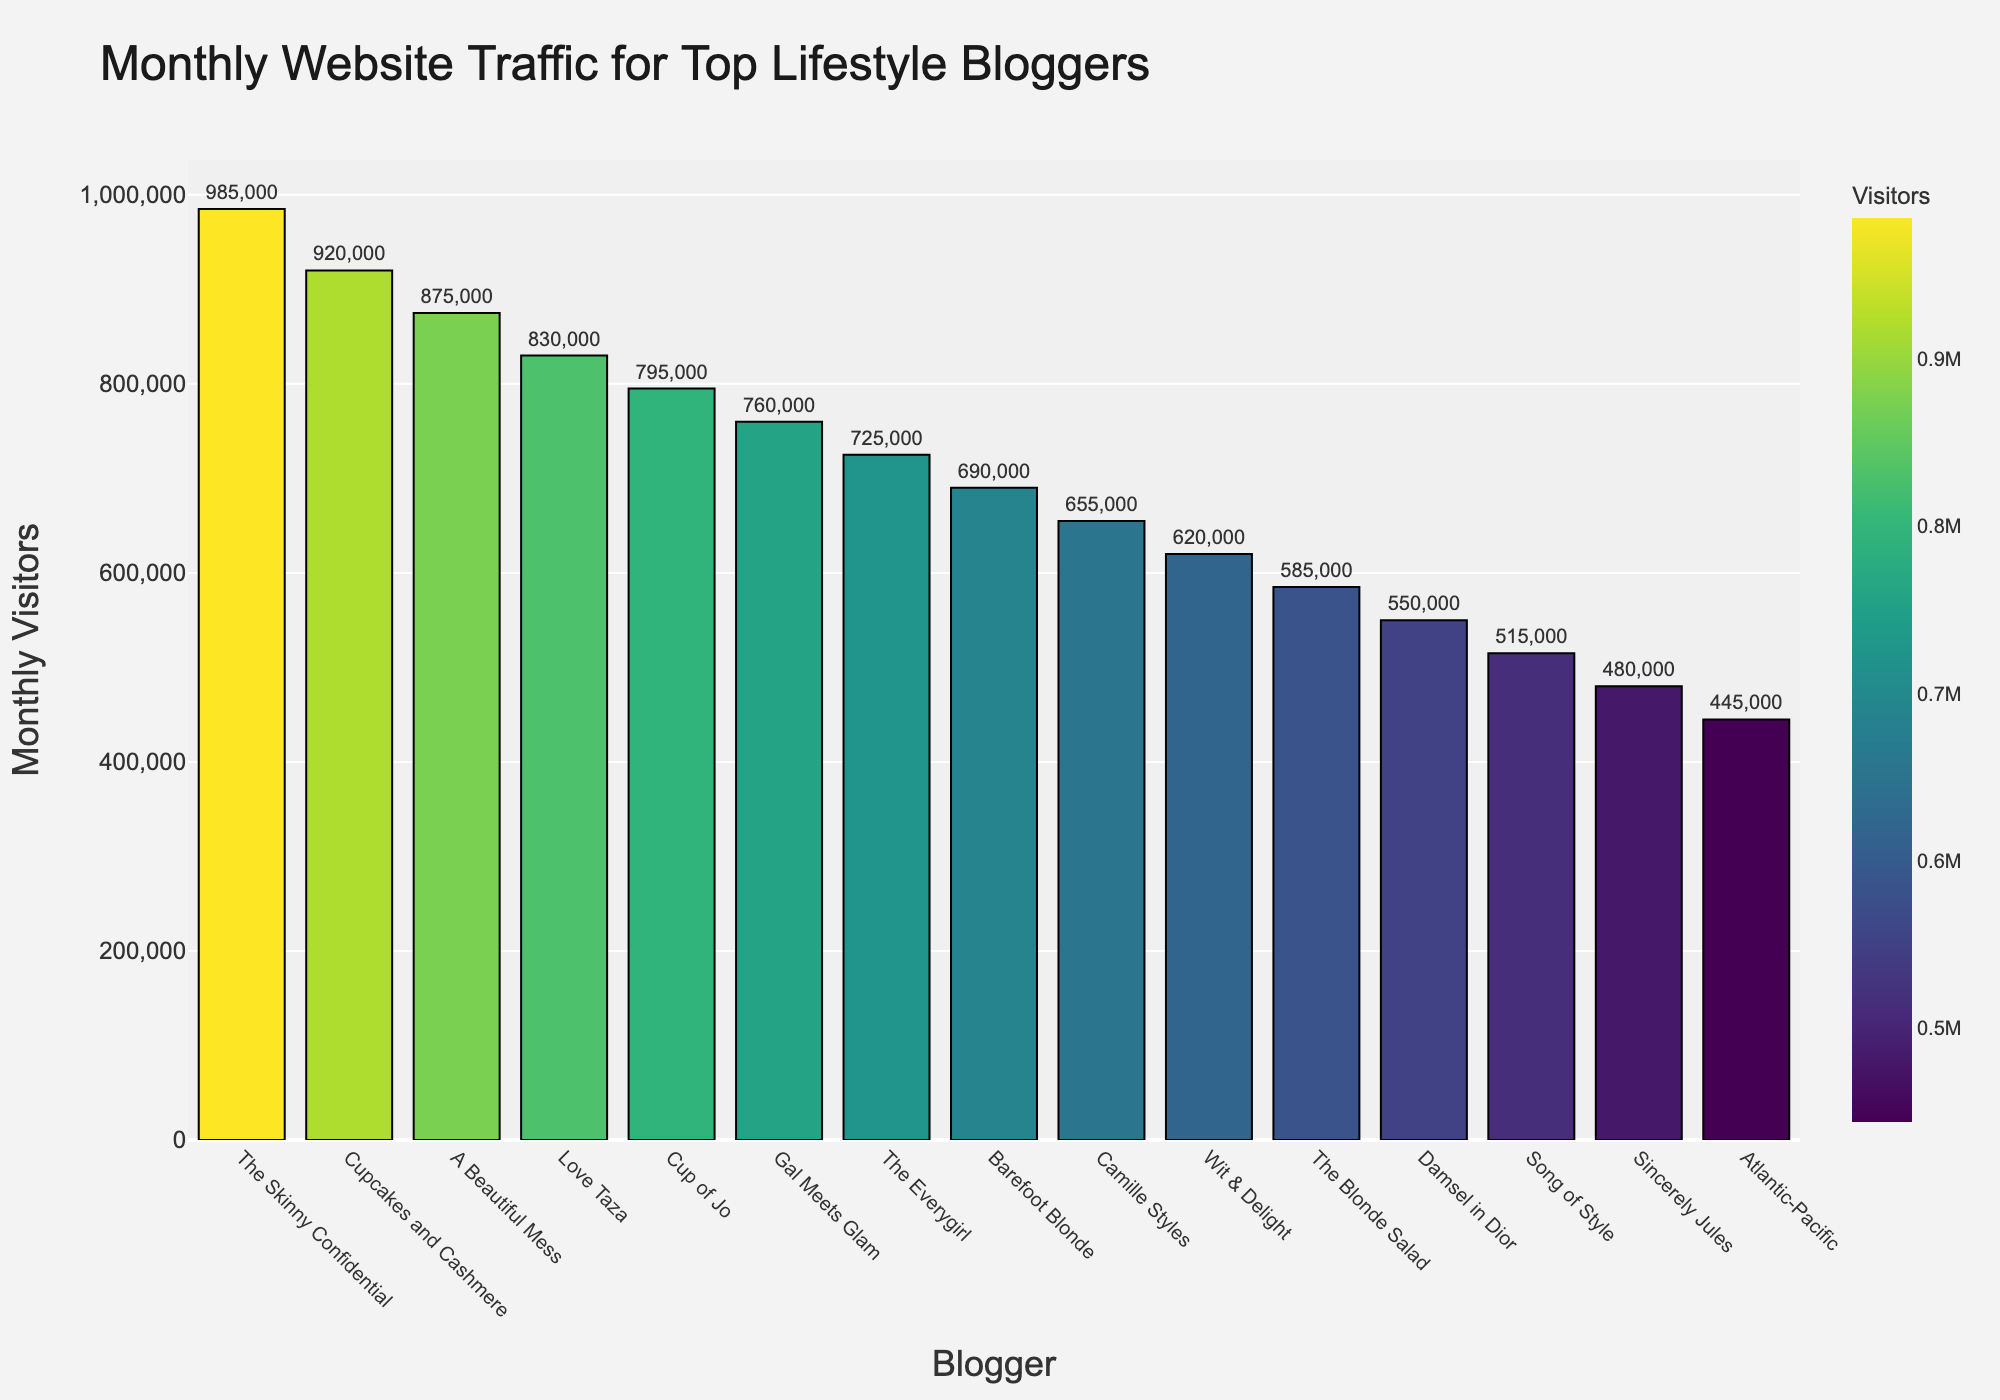Which blogger has the highest monthly visitors? The bar chart shows the height and color intensity of each bar. The tallest and most prominently colored bar corresponds to "The Skinny Confidential" with 985,000 monthly visitors.
Answer: The Skinny Confidential What is the difference in monthly visitors between "Cupcakes and Cashmere" and "Love Taza"? According to the bar chart, "Cupcakes and Cashmere" has 920,000 monthly visitors, while "Love Taza" has 830,000. The difference is 920,000 - 830,000 = 90,000.
Answer: 90,000 What is the median number of monthly visitors among the featured bloggers? To find the median, the visitors' numbers must be sorted in ascending order: 445,000, 480,000, 515,000, 550,000, 585,000, 620,000, 655,000, 690,000, 725,000, 760,000, 795,000, 830,000, 875,000, 920,000, 985,000. The middle value (8th in the list) is 690,000.
Answer: 690,000 Which blogger has fewer monthly visitors: "The Blonde Salad" or "Sincerely Jules"? By inspecting the bar chart, "The Blonde Salad" has 585,000 monthly visitors, and "Sincerely Jules" has 480,000. Therefore, "Sincerely Jules" has fewer monthly visitors.
Answer: Sincerely Jules How many bloggers have monthly visitors more than 800,000? The bar chart indicates that "The Skinny Confidential," "Cupcakes and Cashmere," "A Beautiful Mess," and "Love Taza" have over 800,000 monthly visitors. This totals 4 bloggers.
Answer: 4 What is the total number of monthly visitors for the top three bloggers combined? "The Skinny Confidential" has 985,000 visitors, "Cupcakes and Cashmere" has 920,000 visitors, and "A Beautiful Mess" has 875,000 visitors. Summing these gives 985,000 + 920,000 + 875,000 = 2,780,000.
Answer: 2,780,000 Which blogger has the shortest bar, and how many visitors does this represent? The shortest bar in the chart corresponds to "Atlantic-Pacific," indicating 445,000 monthly visitors.
Answer: Atlantic-Pacific with 445,000 Who has higher monthly visitors: "Camille Styles" or "Barefoot Blonde," and by how much? "Barefoot Blonde" has 690,000 visitors and "Camille Styles" has 655,000. The difference is 690,000 - 655,000 = 35,000, so "Barefoot Blonde" has more visitors by 35,000.
Answer: Barefoot Blonde by 35,000 How many bloggers have monthly visitors between 600,000 and 700,000? The bar chart shows that "The Everygirl" (725,000), "Barefoot Blonde" (690,000), "Camille Styles" (655,000), and "Wit & Delight" (620,000) fall within this range, which totals to 4 bloggers.
Answer: 4 What is the average monthly visitors among all bloggers featured in the chart? Summing all visitors and dividing by the number of bloggers: (985,000 + 920,000 + 875,000 + 830,000 + 795,000 + 760,000 + 725,000 + 690,000 + 655,000 + 620,000 + 585,000 + 550,000 + 515,000 + 480,000 + 445,000) / 15 = 731,667 when rounded to the nearest whole number.
Answer: 731,667 